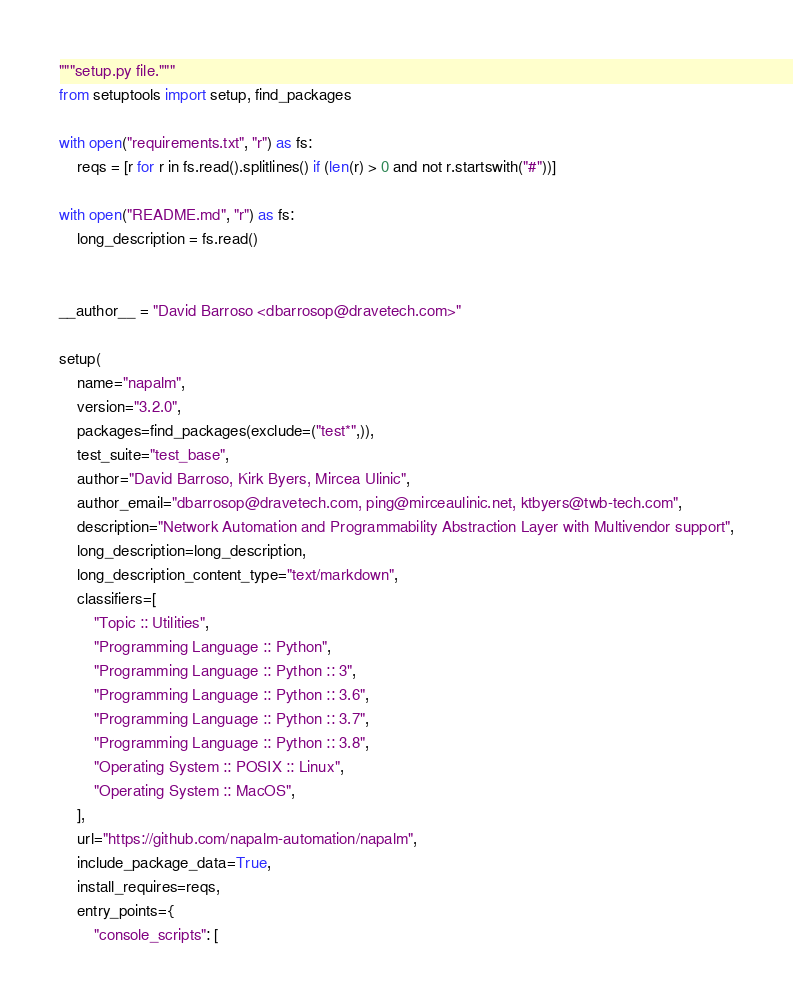<code> <loc_0><loc_0><loc_500><loc_500><_Python_>"""setup.py file."""
from setuptools import setup, find_packages

with open("requirements.txt", "r") as fs:
    reqs = [r for r in fs.read().splitlines() if (len(r) > 0 and not r.startswith("#"))]

with open("README.md", "r") as fs:
    long_description = fs.read()


__author__ = "David Barroso <dbarrosop@dravetech.com>"

setup(
    name="napalm",
    version="3.2.0",
    packages=find_packages(exclude=("test*",)),
    test_suite="test_base",
    author="David Barroso, Kirk Byers, Mircea Ulinic",
    author_email="dbarrosop@dravetech.com, ping@mirceaulinic.net, ktbyers@twb-tech.com",
    description="Network Automation and Programmability Abstraction Layer with Multivendor support",
    long_description=long_description,
    long_description_content_type="text/markdown",
    classifiers=[
        "Topic :: Utilities",
        "Programming Language :: Python",
        "Programming Language :: Python :: 3",
        "Programming Language :: Python :: 3.6",
        "Programming Language :: Python :: 3.7",
        "Programming Language :: Python :: 3.8",
        "Operating System :: POSIX :: Linux",
        "Operating System :: MacOS",
    ],
    url="https://github.com/napalm-automation/napalm",
    include_package_data=True,
    install_requires=reqs,
    entry_points={
        "console_scripts": [</code> 